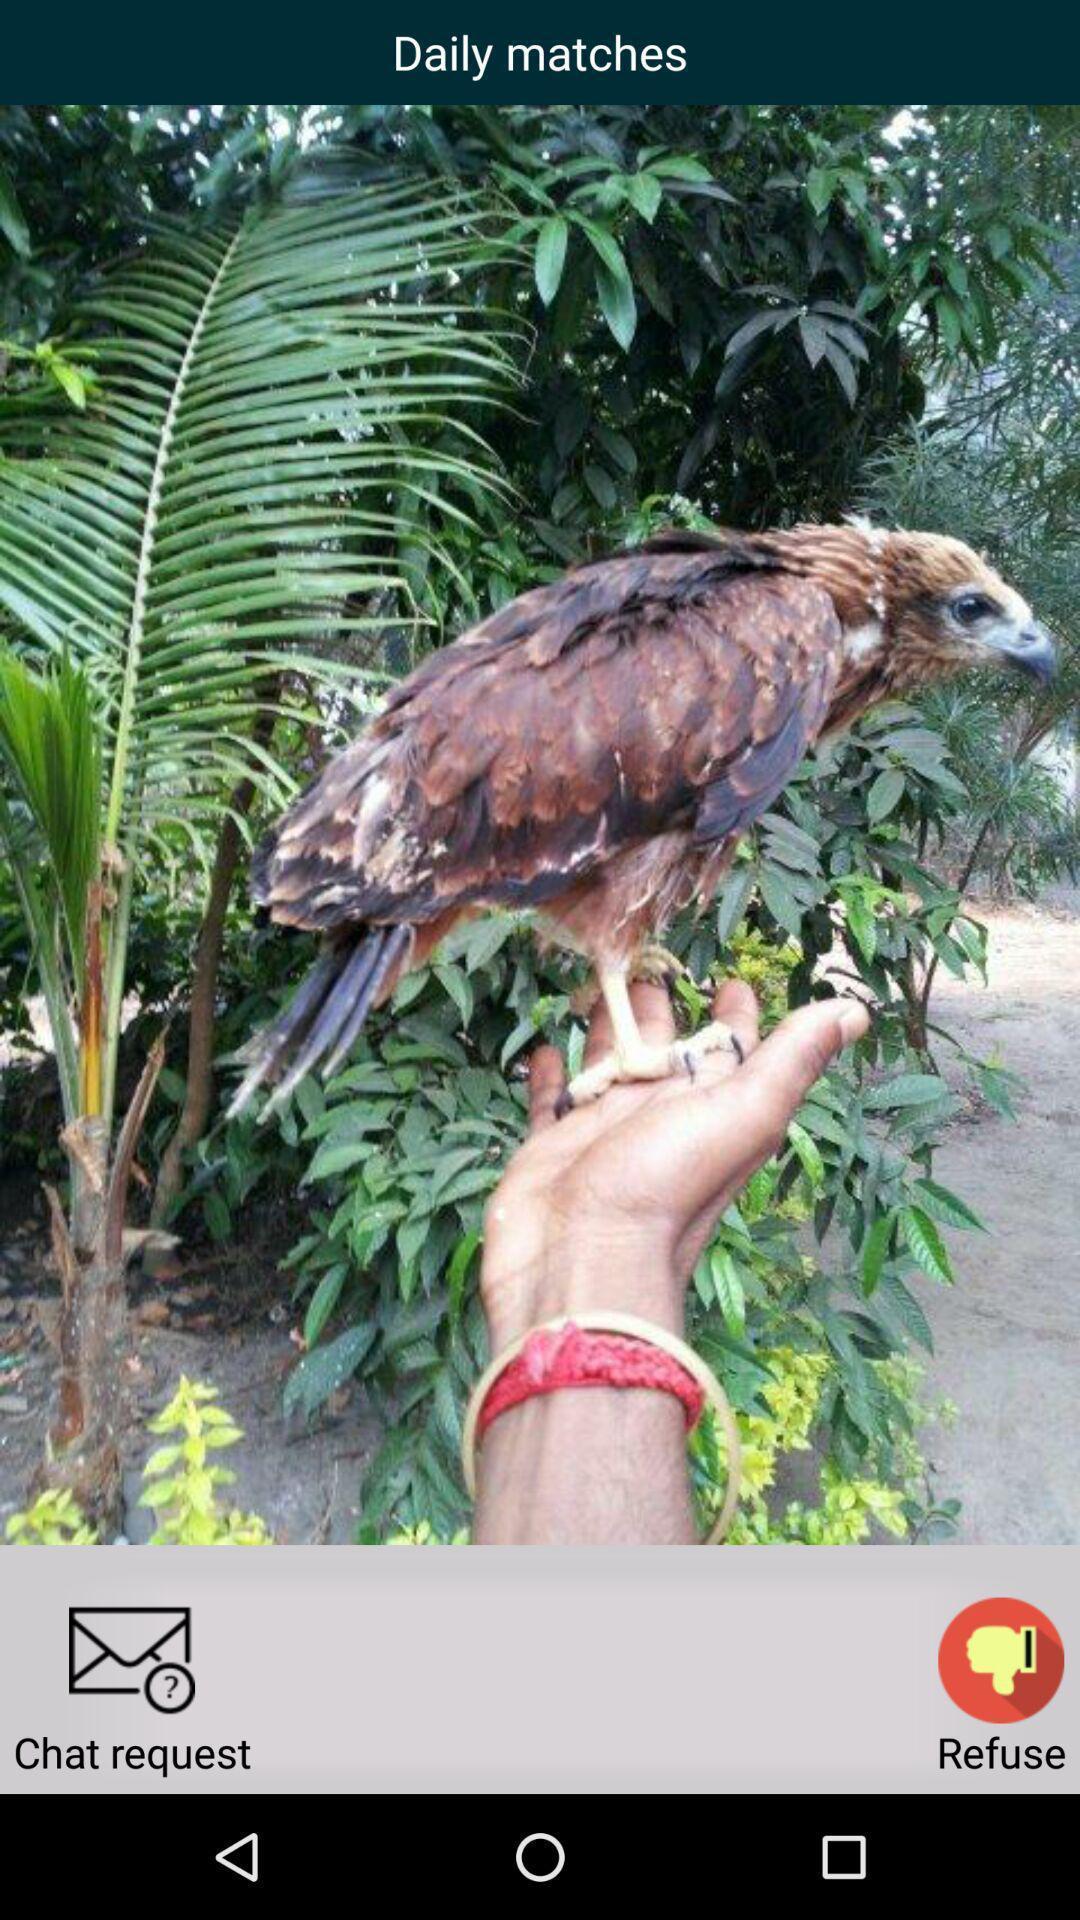Tell me what you see in this picture. Screen displaying page of an social application. 